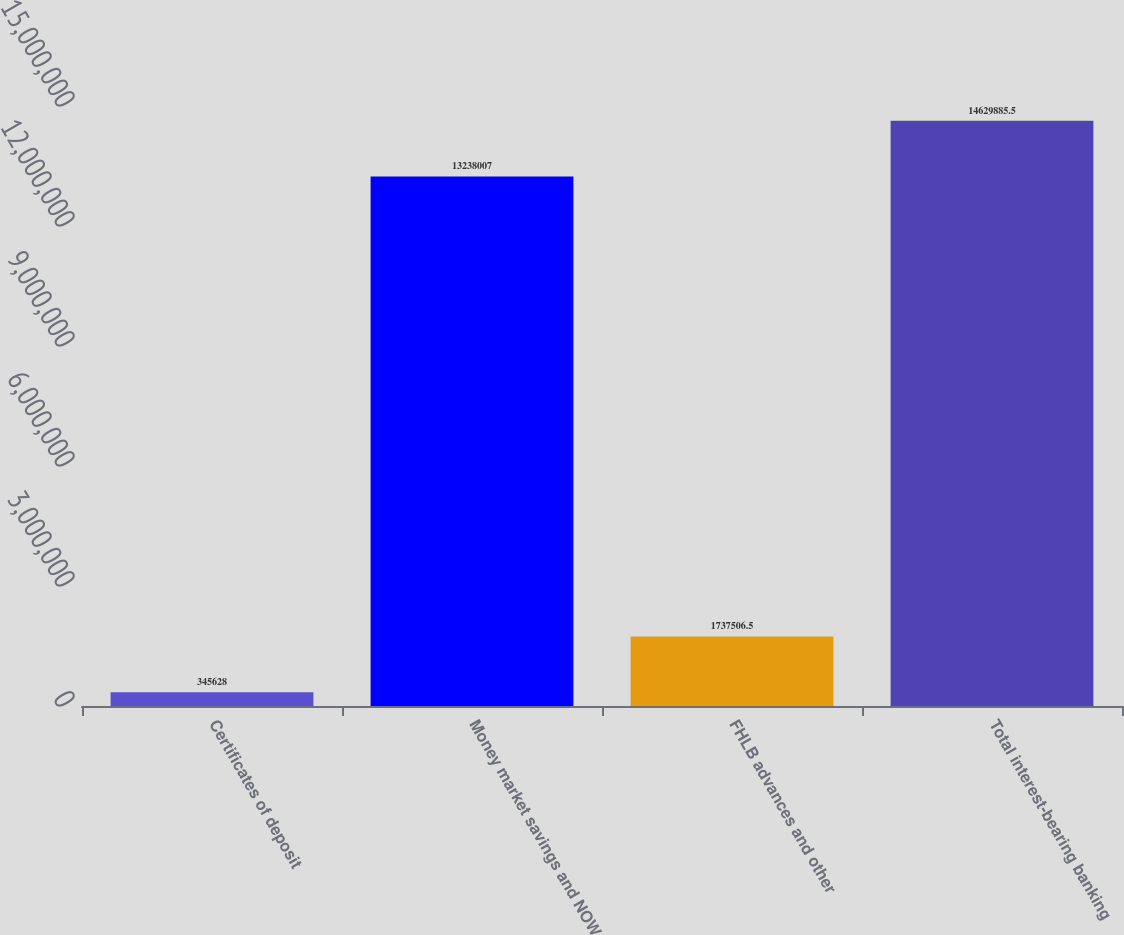<chart> <loc_0><loc_0><loc_500><loc_500><bar_chart><fcel>Certificates of deposit<fcel>Money market savings and NOW<fcel>FHLB advances and other<fcel>Total interest-bearing banking<nl><fcel>345628<fcel>1.3238e+07<fcel>1.73751e+06<fcel>1.46299e+07<nl></chart> 